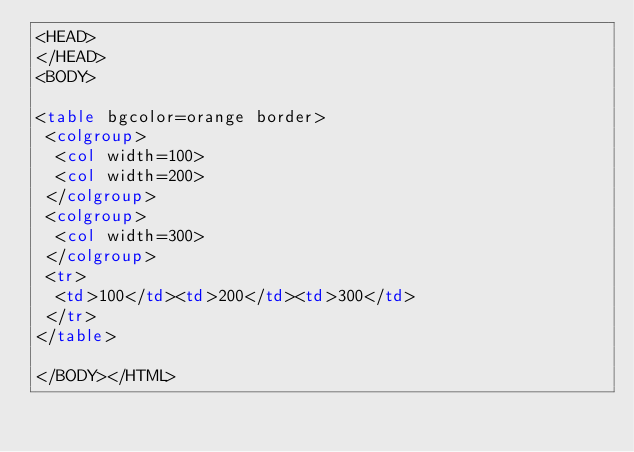<code> <loc_0><loc_0><loc_500><loc_500><_HTML_><HEAD>
</HEAD>
<BODY>

<table bgcolor=orange border>
 <colgroup>
  <col width=100>
  <col width=200>
 </colgroup>
 <colgroup>
  <col width=300>
 </colgroup>
 <tr>
  <td>100</td><td>200</td><td>300</td>
 </tr>
</table>

</BODY></HTML>

</code> 